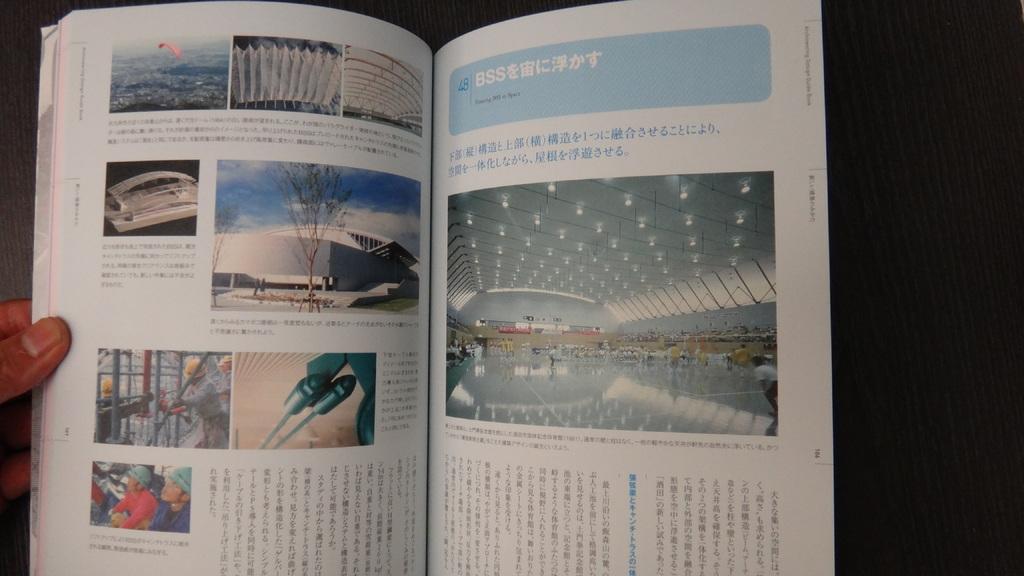What is the chapter number?
Offer a very short reply. Unanswerable. 